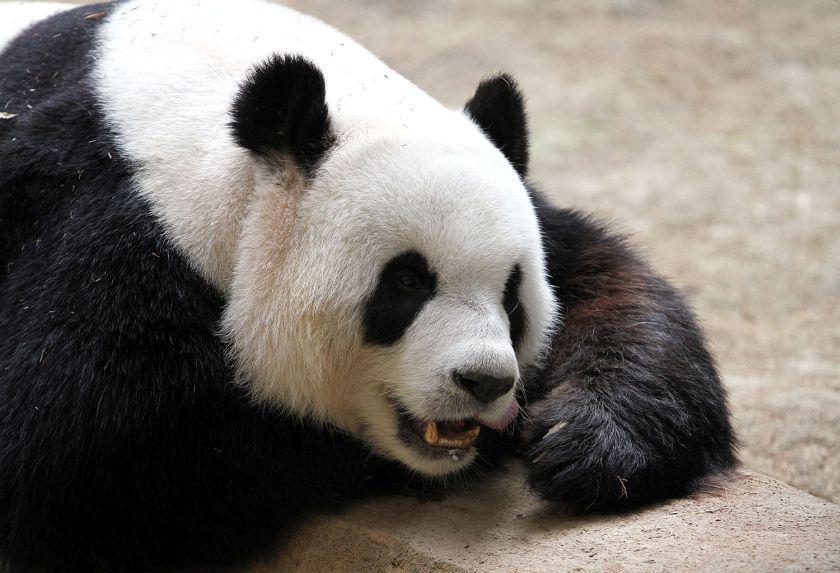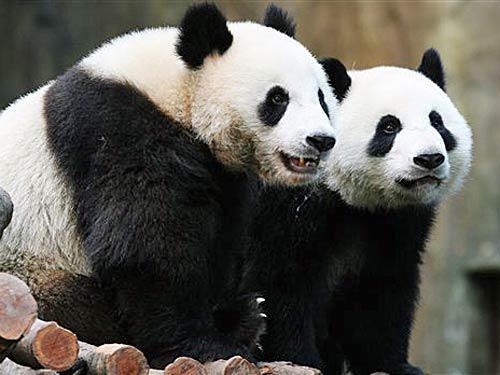The first image is the image on the left, the second image is the image on the right. Assess this claim about the two images: "Right image contains twice as many panda bears as the left image.". Correct or not? Answer yes or no. Yes. The first image is the image on the left, the second image is the image on the right. Examine the images to the left and right. Is the description "There are no more than three pandas." accurate? Answer yes or no. Yes. 